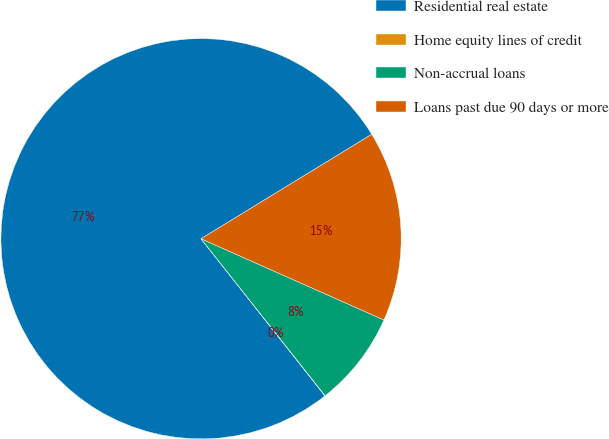Convert chart to OTSL. <chart><loc_0><loc_0><loc_500><loc_500><pie_chart><fcel>Residential real estate<fcel>Home equity lines of credit<fcel>Non-accrual loans<fcel>Loans past due 90 days or more<nl><fcel>76.89%<fcel>0.02%<fcel>7.7%<fcel>15.39%<nl></chart> 